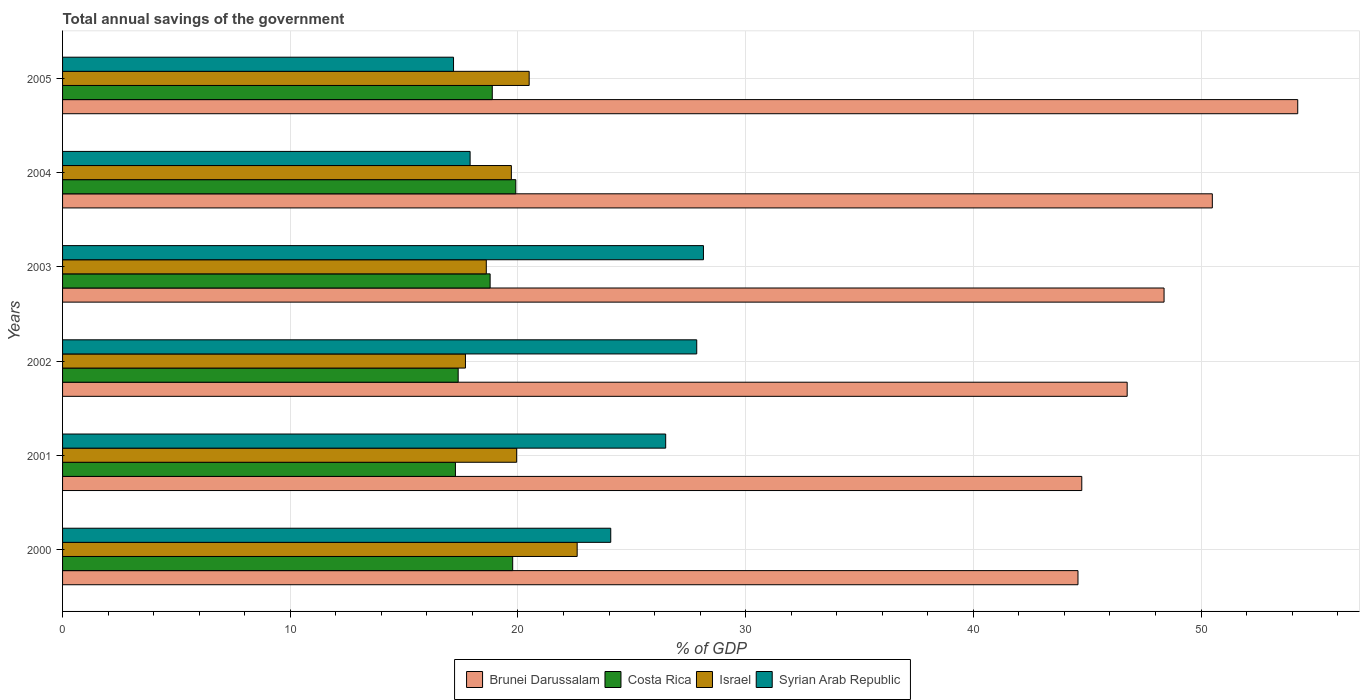How many different coloured bars are there?
Your answer should be compact. 4. How many groups of bars are there?
Provide a short and direct response. 6. Are the number of bars on each tick of the Y-axis equal?
Provide a short and direct response. Yes. How many bars are there on the 2nd tick from the top?
Offer a very short reply. 4. What is the total annual savings of the government in Brunei Darussalam in 2001?
Your response must be concise. 44.76. Across all years, what is the maximum total annual savings of the government in Brunei Darussalam?
Ensure brevity in your answer.  54.25. Across all years, what is the minimum total annual savings of the government in Israel?
Offer a very short reply. 17.69. In which year was the total annual savings of the government in Israel maximum?
Offer a very short reply. 2000. In which year was the total annual savings of the government in Brunei Darussalam minimum?
Your answer should be very brief. 2000. What is the total total annual savings of the government in Brunei Darussalam in the graph?
Offer a very short reply. 289.23. What is the difference between the total annual savings of the government in Syrian Arab Republic in 2003 and that in 2004?
Your answer should be very brief. 10.25. What is the difference between the total annual savings of the government in Costa Rica in 2005 and the total annual savings of the government in Brunei Darussalam in 2002?
Your answer should be very brief. -27.88. What is the average total annual savings of the government in Syrian Arab Republic per year?
Ensure brevity in your answer.  23.6. In the year 2001, what is the difference between the total annual savings of the government in Syrian Arab Republic and total annual savings of the government in Israel?
Provide a short and direct response. 6.55. What is the ratio of the total annual savings of the government in Brunei Darussalam in 2002 to that in 2003?
Your answer should be compact. 0.97. What is the difference between the highest and the second highest total annual savings of the government in Costa Rica?
Offer a very short reply. 0.14. What is the difference between the highest and the lowest total annual savings of the government in Costa Rica?
Your response must be concise. 2.65. In how many years, is the total annual savings of the government in Israel greater than the average total annual savings of the government in Israel taken over all years?
Your response must be concise. 3. Is the sum of the total annual savings of the government in Syrian Arab Republic in 2004 and 2005 greater than the maximum total annual savings of the government in Brunei Darussalam across all years?
Provide a succinct answer. No. What does the 2nd bar from the bottom in 2000 represents?
Provide a succinct answer. Costa Rica. How many bars are there?
Your response must be concise. 24. Are all the bars in the graph horizontal?
Your answer should be compact. Yes. How many years are there in the graph?
Provide a short and direct response. 6. Are the values on the major ticks of X-axis written in scientific E-notation?
Give a very brief answer. No. Does the graph contain grids?
Your answer should be very brief. Yes. Where does the legend appear in the graph?
Offer a very short reply. Bottom center. How many legend labels are there?
Keep it short and to the point. 4. What is the title of the graph?
Make the answer very short. Total annual savings of the government. Does "Liechtenstein" appear as one of the legend labels in the graph?
Offer a very short reply. No. What is the label or title of the X-axis?
Provide a succinct answer. % of GDP. What is the % of GDP of Brunei Darussalam in 2000?
Your answer should be very brief. 44.59. What is the % of GDP in Costa Rica in 2000?
Your answer should be very brief. 19.77. What is the % of GDP of Israel in 2000?
Your answer should be very brief. 22.6. What is the % of GDP in Syrian Arab Republic in 2000?
Offer a very short reply. 24.08. What is the % of GDP in Brunei Darussalam in 2001?
Ensure brevity in your answer.  44.76. What is the % of GDP in Costa Rica in 2001?
Your response must be concise. 17.25. What is the % of GDP in Israel in 2001?
Your answer should be very brief. 19.94. What is the % of GDP of Syrian Arab Republic in 2001?
Provide a succinct answer. 26.49. What is the % of GDP of Brunei Darussalam in 2002?
Ensure brevity in your answer.  46.76. What is the % of GDP of Costa Rica in 2002?
Give a very brief answer. 17.37. What is the % of GDP in Israel in 2002?
Your answer should be very brief. 17.69. What is the % of GDP of Syrian Arab Republic in 2002?
Your answer should be very brief. 27.85. What is the % of GDP of Brunei Darussalam in 2003?
Ensure brevity in your answer.  48.38. What is the % of GDP in Costa Rica in 2003?
Offer a terse response. 18.78. What is the % of GDP in Israel in 2003?
Offer a very short reply. 18.61. What is the % of GDP of Syrian Arab Republic in 2003?
Make the answer very short. 28.15. What is the % of GDP in Brunei Darussalam in 2004?
Keep it short and to the point. 50.49. What is the % of GDP in Costa Rica in 2004?
Provide a succinct answer. 19.91. What is the % of GDP of Israel in 2004?
Give a very brief answer. 19.71. What is the % of GDP of Syrian Arab Republic in 2004?
Your answer should be very brief. 17.9. What is the % of GDP of Brunei Darussalam in 2005?
Keep it short and to the point. 54.25. What is the % of GDP of Costa Rica in 2005?
Your answer should be very brief. 18.87. What is the % of GDP of Israel in 2005?
Ensure brevity in your answer.  20.49. What is the % of GDP of Syrian Arab Republic in 2005?
Offer a very short reply. 17.17. Across all years, what is the maximum % of GDP of Brunei Darussalam?
Offer a very short reply. 54.25. Across all years, what is the maximum % of GDP of Costa Rica?
Offer a very short reply. 19.91. Across all years, what is the maximum % of GDP of Israel?
Offer a very short reply. 22.6. Across all years, what is the maximum % of GDP of Syrian Arab Republic?
Give a very brief answer. 28.15. Across all years, what is the minimum % of GDP of Brunei Darussalam?
Provide a succinct answer. 44.59. Across all years, what is the minimum % of GDP of Costa Rica?
Provide a succinct answer. 17.25. Across all years, what is the minimum % of GDP of Israel?
Offer a very short reply. 17.69. Across all years, what is the minimum % of GDP of Syrian Arab Republic?
Keep it short and to the point. 17.17. What is the total % of GDP of Brunei Darussalam in the graph?
Keep it short and to the point. 289.23. What is the total % of GDP of Costa Rica in the graph?
Give a very brief answer. 111.95. What is the total % of GDP of Israel in the graph?
Ensure brevity in your answer.  119.05. What is the total % of GDP of Syrian Arab Republic in the graph?
Offer a terse response. 141.63. What is the difference between the % of GDP in Brunei Darussalam in 2000 and that in 2001?
Ensure brevity in your answer.  -0.17. What is the difference between the % of GDP of Costa Rica in 2000 and that in 2001?
Give a very brief answer. 2.51. What is the difference between the % of GDP of Israel in 2000 and that in 2001?
Offer a terse response. 2.66. What is the difference between the % of GDP of Syrian Arab Republic in 2000 and that in 2001?
Offer a very short reply. -2.41. What is the difference between the % of GDP in Brunei Darussalam in 2000 and that in 2002?
Give a very brief answer. -2.16. What is the difference between the % of GDP of Costa Rica in 2000 and that in 2002?
Offer a terse response. 2.39. What is the difference between the % of GDP of Israel in 2000 and that in 2002?
Provide a succinct answer. 4.91. What is the difference between the % of GDP of Syrian Arab Republic in 2000 and that in 2002?
Ensure brevity in your answer.  -3.78. What is the difference between the % of GDP of Brunei Darussalam in 2000 and that in 2003?
Make the answer very short. -3.78. What is the difference between the % of GDP in Costa Rica in 2000 and that in 2003?
Your response must be concise. 0.99. What is the difference between the % of GDP in Israel in 2000 and that in 2003?
Your response must be concise. 3.99. What is the difference between the % of GDP in Syrian Arab Republic in 2000 and that in 2003?
Your answer should be compact. -4.07. What is the difference between the % of GDP in Costa Rica in 2000 and that in 2004?
Your answer should be very brief. -0.14. What is the difference between the % of GDP of Israel in 2000 and that in 2004?
Make the answer very short. 2.89. What is the difference between the % of GDP of Syrian Arab Republic in 2000 and that in 2004?
Your answer should be very brief. 6.18. What is the difference between the % of GDP of Brunei Darussalam in 2000 and that in 2005?
Make the answer very short. -9.65. What is the difference between the % of GDP in Costa Rica in 2000 and that in 2005?
Ensure brevity in your answer.  0.9. What is the difference between the % of GDP in Israel in 2000 and that in 2005?
Give a very brief answer. 2.11. What is the difference between the % of GDP in Syrian Arab Republic in 2000 and that in 2005?
Ensure brevity in your answer.  6.91. What is the difference between the % of GDP in Brunei Darussalam in 2001 and that in 2002?
Ensure brevity in your answer.  -1.99. What is the difference between the % of GDP of Costa Rica in 2001 and that in 2002?
Make the answer very short. -0.12. What is the difference between the % of GDP in Israel in 2001 and that in 2002?
Your answer should be very brief. 2.25. What is the difference between the % of GDP in Syrian Arab Republic in 2001 and that in 2002?
Ensure brevity in your answer.  -1.36. What is the difference between the % of GDP of Brunei Darussalam in 2001 and that in 2003?
Make the answer very short. -3.61. What is the difference between the % of GDP of Costa Rica in 2001 and that in 2003?
Ensure brevity in your answer.  -1.52. What is the difference between the % of GDP of Israel in 2001 and that in 2003?
Offer a terse response. 1.33. What is the difference between the % of GDP of Syrian Arab Republic in 2001 and that in 2003?
Your answer should be compact. -1.66. What is the difference between the % of GDP in Brunei Darussalam in 2001 and that in 2004?
Provide a short and direct response. -5.73. What is the difference between the % of GDP in Costa Rica in 2001 and that in 2004?
Your answer should be compact. -2.65. What is the difference between the % of GDP of Israel in 2001 and that in 2004?
Give a very brief answer. 0.23. What is the difference between the % of GDP in Syrian Arab Republic in 2001 and that in 2004?
Provide a short and direct response. 8.59. What is the difference between the % of GDP of Brunei Darussalam in 2001 and that in 2005?
Offer a terse response. -9.48. What is the difference between the % of GDP in Costa Rica in 2001 and that in 2005?
Make the answer very short. -1.62. What is the difference between the % of GDP in Israel in 2001 and that in 2005?
Provide a succinct answer. -0.55. What is the difference between the % of GDP of Syrian Arab Republic in 2001 and that in 2005?
Ensure brevity in your answer.  9.32. What is the difference between the % of GDP in Brunei Darussalam in 2002 and that in 2003?
Offer a terse response. -1.62. What is the difference between the % of GDP in Costa Rica in 2002 and that in 2003?
Give a very brief answer. -1.4. What is the difference between the % of GDP of Israel in 2002 and that in 2003?
Your answer should be compact. -0.92. What is the difference between the % of GDP of Syrian Arab Republic in 2002 and that in 2003?
Your answer should be compact. -0.29. What is the difference between the % of GDP in Brunei Darussalam in 2002 and that in 2004?
Provide a succinct answer. -3.74. What is the difference between the % of GDP of Costa Rica in 2002 and that in 2004?
Give a very brief answer. -2.53. What is the difference between the % of GDP in Israel in 2002 and that in 2004?
Your answer should be very brief. -2.02. What is the difference between the % of GDP in Syrian Arab Republic in 2002 and that in 2004?
Make the answer very short. 9.95. What is the difference between the % of GDP of Brunei Darussalam in 2002 and that in 2005?
Keep it short and to the point. -7.49. What is the difference between the % of GDP in Costa Rica in 2002 and that in 2005?
Your response must be concise. -1.5. What is the difference between the % of GDP in Israel in 2002 and that in 2005?
Offer a terse response. -2.8. What is the difference between the % of GDP of Syrian Arab Republic in 2002 and that in 2005?
Provide a short and direct response. 10.68. What is the difference between the % of GDP of Brunei Darussalam in 2003 and that in 2004?
Make the answer very short. -2.12. What is the difference between the % of GDP of Costa Rica in 2003 and that in 2004?
Make the answer very short. -1.13. What is the difference between the % of GDP in Israel in 2003 and that in 2004?
Your answer should be compact. -1.1. What is the difference between the % of GDP in Syrian Arab Republic in 2003 and that in 2004?
Make the answer very short. 10.25. What is the difference between the % of GDP in Brunei Darussalam in 2003 and that in 2005?
Keep it short and to the point. -5.87. What is the difference between the % of GDP of Costa Rica in 2003 and that in 2005?
Ensure brevity in your answer.  -0.09. What is the difference between the % of GDP of Israel in 2003 and that in 2005?
Provide a succinct answer. -1.88. What is the difference between the % of GDP of Syrian Arab Republic in 2003 and that in 2005?
Your answer should be compact. 10.98. What is the difference between the % of GDP in Brunei Darussalam in 2004 and that in 2005?
Ensure brevity in your answer.  -3.75. What is the difference between the % of GDP in Costa Rica in 2004 and that in 2005?
Provide a succinct answer. 1.03. What is the difference between the % of GDP of Israel in 2004 and that in 2005?
Your answer should be very brief. -0.78. What is the difference between the % of GDP of Syrian Arab Republic in 2004 and that in 2005?
Provide a short and direct response. 0.73. What is the difference between the % of GDP of Brunei Darussalam in 2000 and the % of GDP of Costa Rica in 2001?
Provide a short and direct response. 27.34. What is the difference between the % of GDP in Brunei Darussalam in 2000 and the % of GDP in Israel in 2001?
Offer a very short reply. 24.65. What is the difference between the % of GDP in Brunei Darussalam in 2000 and the % of GDP in Syrian Arab Republic in 2001?
Your answer should be compact. 18.11. What is the difference between the % of GDP of Costa Rica in 2000 and the % of GDP of Israel in 2001?
Provide a short and direct response. -0.17. What is the difference between the % of GDP of Costa Rica in 2000 and the % of GDP of Syrian Arab Republic in 2001?
Provide a succinct answer. -6.72. What is the difference between the % of GDP of Israel in 2000 and the % of GDP of Syrian Arab Republic in 2001?
Make the answer very short. -3.89. What is the difference between the % of GDP in Brunei Darussalam in 2000 and the % of GDP in Costa Rica in 2002?
Your answer should be very brief. 27.22. What is the difference between the % of GDP in Brunei Darussalam in 2000 and the % of GDP in Israel in 2002?
Ensure brevity in your answer.  26.9. What is the difference between the % of GDP of Brunei Darussalam in 2000 and the % of GDP of Syrian Arab Republic in 2002?
Your answer should be compact. 16.74. What is the difference between the % of GDP in Costa Rica in 2000 and the % of GDP in Israel in 2002?
Your answer should be very brief. 2.07. What is the difference between the % of GDP of Costa Rica in 2000 and the % of GDP of Syrian Arab Republic in 2002?
Provide a short and direct response. -8.08. What is the difference between the % of GDP in Israel in 2000 and the % of GDP in Syrian Arab Republic in 2002?
Provide a succinct answer. -5.25. What is the difference between the % of GDP in Brunei Darussalam in 2000 and the % of GDP in Costa Rica in 2003?
Offer a terse response. 25.82. What is the difference between the % of GDP of Brunei Darussalam in 2000 and the % of GDP of Israel in 2003?
Your answer should be compact. 25.99. What is the difference between the % of GDP in Brunei Darussalam in 2000 and the % of GDP in Syrian Arab Republic in 2003?
Your answer should be very brief. 16.45. What is the difference between the % of GDP of Costa Rica in 2000 and the % of GDP of Israel in 2003?
Offer a very short reply. 1.16. What is the difference between the % of GDP in Costa Rica in 2000 and the % of GDP in Syrian Arab Republic in 2003?
Make the answer very short. -8.38. What is the difference between the % of GDP in Israel in 2000 and the % of GDP in Syrian Arab Republic in 2003?
Provide a succinct answer. -5.55. What is the difference between the % of GDP in Brunei Darussalam in 2000 and the % of GDP in Costa Rica in 2004?
Ensure brevity in your answer.  24.69. What is the difference between the % of GDP in Brunei Darussalam in 2000 and the % of GDP in Israel in 2004?
Your answer should be compact. 24.88. What is the difference between the % of GDP in Brunei Darussalam in 2000 and the % of GDP in Syrian Arab Republic in 2004?
Your answer should be very brief. 26.7. What is the difference between the % of GDP in Costa Rica in 2000 and the % of GDP in Israel in 2004?
Offer a terse response. 0.06. What is the difference between the % of GDP in Costa Rica in 2000 and the % of GDP in Syrian Arab Republic in 2004?
Your response must be concise. 1.87. What is the difference between the % of GDP in Israel in 2000 and the % of GDP in Syrian Arab Republic in 2004?
Offer a very short reply. 4.7. What is the difference between the % of GDP in Brunei Darussalam in 2000 and the % of GDP in Costa Rica in 2005?
Provide a succinct answer. 25.72. What is the difference between the % of GDP in Brunei Darussalam in 2000 and the % of GDP in Israel in 2005?
Your answer should be very brief. 24.1. What is the difference between the % of GDP of Brunei Darussalam in 2000 and the % of GDP of Syrian Arab Republic in 2005?
Make the answer very short. 27.42. What is the difference between the % of GDP of Costa Rica in 2000 and the % of GDP of Israel in 2005?
Offer a terse response. -0.72. What is the difference between the % of GDP in Costa Rica in 2000 and the % of GDP in Syrian Arab Republic in 2005?
Provide a short and direct response. 2.6. What is the difference between the % of GDP in Israel in 2000 and the % of GDP in Syrian Arab Republic in 2005?
Give a very brief answer. 5.43. What is the difference between the % of GDP of Brunei Darussalam in 2001 and the % of GDP of Costa Rica in 2002?
Offer a terse response. 27.39. What is the difference between the % of GDP of Brunei Darussalam in 2001 and the % of GDP of Israel in 2002?
Make the answer very short. 27.07. What is the difference between the % of GDP of Brunei Darussalam in 2001 and the % of GDP of Syrian Arab Republic in 2002?
Your answer should be very brief. 16.91. What is the difference between the % of GDP in Costa Rica in 2001 and the % of GDP in Israel in 2002?
Ensure brevity in your answer.  -0.44. What is the difference between the % of GDP in Costa Rica in 2001 and the % of GDP in Syrian Arab Republic in 2002?
Your answer should be very brief. -10.6. What is the difference between the % of GDP in Israel in 2001 and the % of GDP in Syrian Arab Republic in 2002?
Keep it short and to the point. -7.91. What is the difference between the % of GDP of Brunei Darussalam in 2001 and the % of GDP of Costa Rica in 2003?
Make the answer very short. 25.98. What is the difference between the % of GDP of Brunei Darussalam in 2001 and the % of GDP of Israel in 2003?
Offer a very short reply. 26.15. What is the difference between the % of GDP of Brunei Darussalam in 2001 and the % of GDP of Syrian Arab Republic in 2003?
Offer a very short reply. 16.62. What is the difference between the % of GDP of Costa Rica in 2001 and the % of GDP of Israel in 2003?
Your answer should be very brief. -1.36. What is the difference between the % of GDP in Costa Rica in 2001 and the % of GDP in Syrian Arab Republic in 2003?
Your response must be concise. -10.89. What is the difference between the % of GDP in Israel in 2001 and the % of GDP in Syrian Arab Republic in 2003?
Provide a short and direct response. -8.2. What is the difference between the % of GDP in Brunei Darussalam in 2001 and the % of GDP in Costa Rica in 2004?
Your answer should be compact. 24.86. What is the difference between the % of GDP in Brunei Darussalam in 2001 and the % of GDP in Israel in 2004?
Keep it short and to the point. 25.05. What is the difference between the % of GDP in Brunei Darussalam in 2001 and the % of GDP in Syrian Arab Republic in 2004?
Ensure brevity in your answer.  26.86. What is the difference between the % of GDP in Costa Rica in 2001 and the % of GDP in Israel in 2004?
Your answer should be compact. -2.46. What is the difference between the % of GDP of Costa Rica in 2001 and the % of GDP of Syrian Arab Republic in 2004?
Provide a succinct answer. -0.64. What is the difference between the % of GDP in Israel in 2001 and the % of GDP in Syrian Arab Republic in 2004?
Your answer should be very brief. 2.04. What is the difference between the % of GDP of Brunei Darussalam in 2001 and the % of GDP of Costa Rica in 2005?
Give a very brief answer. 25.89. What is the difference between the % of GDP of Brunei Darussalam in 2001 and the % of GDP of Israel in 2005?
Your response must be concise. 24.27. What is the difference between the % of GDP in Brunei Darussalam in 2001 and the % of GDP in Syrian Arab Republic in 2005?
Your answer should be compact. 27.59. What is the difference between the % of GDP in Costa Rica in 2001 and the % of GDP in Israel in 2005?
Give a very brief answer. -3.24. What is the difference between the % of GDP in Costa Rica in 2001 and the % of GDP in Syrian Arab Republic in 2005?
Provide a succinct answer. 0.08. What is the difference between the % of GDP in Israel in 2001 and the % of GDP in Syrian Arab Republic in 2005?
Your response must be concise. 2.77. What is the difference between the % of GDP of Brunei Darussalam in 2002 and the % of GDP of Costa Rica in 2003?
Your answer should be compact. 27.98. What is the difference between the % of GDP of Brunei Darussalam in 2002 and the % of GDP of Israel in 2003?
Your answer should be compact. 28.15. What is the difference between the % of GDP of Brunei Darussalam in 2002 and the % of GDP of Syrian Arab Republic in 2003?
Provide a succinct answer. 18.61. What is the difference between the % of GDP of Costa Rica in 2002 and the % of GDP of Israel in 2003?
Make the answer very short. -1.23. What is the difference between the % of GDP in Costa Rica in 2002 and the % of GDP in Syrian Arab Republic in 2003?
Your answer should be compact. -10.77. What is the difference between the % of GDP of Israel in 2002 and the % of GDP of Syrian Arab Republic in 2003?
Your answer should be very brief. -10.45. What is the difference between the % of GDP of Brunei Darussalam in 2002 and the % of GDP of Costa Rica in 2004?
Offer a terse response. 26.85. What is the difference between the % of GDP of Brunei Darussalam in 2002 and the % of GDP of Israel in 2004?
Make the answer very short. 27.05. What is the difference between the % of GDP of Brunei Darussalam in 2002 and the % of GDP of Syrian Arab Republic in 2004?
Your answer should be very brief. 28.86. What is the difference between the % of GDP of Costa Rica in 2002 and the % of GDP of Israel in 2004?
Your answer should be very brief. -2.34. What is the difference between the % of GDP of Costa Rica in 2002 and the % of GDP of Syrian Arab Republic in 2004?
Your response must be concise. -0.52. What is the difference between the % of GDP of Israel in 2002 and the % of GDP of Syrian Arab Republic in 2004?
Provide a succinct answer. -0.2. What is the difference between the % of GDP in Brunei Darussalam in 2002 and the % of GDP in Costa Rica in 2005?
Make the answer very short. 27.88. What is the difference between the % of GDP of Brunei Darussalam in 2002 and the % of GDP of Israel in 2005?
Give a very brief answer. 26.26. What is the difference between the % of GDP in Brunei Darussalam in 2002 and the % of GDP in Syrian Arab Republic in 2005?
Your answer should be compact. 29.59. What is the difference between the % of GDP in Costa Rica in 2002 and the % of GDP in Israel in 2005?
Your response must be concise. -3.12. What is the difference between the % of GDP in Costa Rica in 2002 and the % of GDP in Syrian Arab Republic in 2005?
Ensure brevity in your answer.  0.2. What is the difference between the % of GDP in Israel in 2002 and the % of GDP in Syrian Arab Republic in 2005?
Keep it short and to the point. 0.52. What is the difference between the % of GDP of Brunei Darussalam in 2003 and the % of GDP of Costa Rica in 2004?
Provide a short and direct response. 28.47. What is the difference between the % of GDP in Brunei Darussalam in 2003 and the % of GDP in Israel in 2004?
Make the answer very short. 28.67. What is the difference between the % of GDP in Brunei Darussalam in 2003 and the % of GDP in Syrian Arab Republic in 2004?
Make the answer very short. 30.48. What is the difference between the % of GDP of Costa Rica in 2003 and the % of GDP of Israel in 2004?
Provide a short and direct response. -0.93. What is the difference between the % of GDP in Costa Rica in 2003 and the % of GDP in Syrian Arab Republic in 2004?
Keep it short and to the point. 0.88. What is the difference between the % of GDP of Israel in 2003 and the % of GDP of Syrian Arab Republic in 2004?
Make the answer very short. 0.71. What is the difference between the % of GDP of Brunei Darussalam in 2003 and the % of GDP of Costa Rica in 2005?
Make the answer very short. 29.5. What is the difference between the % of GDP of Brunei Darussalam in 2003 and the % of GDP of Israel in 2005?
Keep it short and to the point. 27.88. What is the difference between the % of GDP in Brunei Darussalam in 2003 and the % of GDP in Syrian Arab Republic in 2005?
Provide a succinct answer. 31.21. What is the difference between the % of GDP in Costa Rica in 2003 and the % of GDP in Israel in 2005?
Make the answer very short. -1.72. What is the difference between the % of GDP of Costa Rica in 2003 and the % of GDP of Syrian Arab Republic in 2005?
Keep it short and to the point. 1.61. What is the difference between the % of GDP of Israel in 2003 and the % of GDP of Syrian Arab Republic in 2005?
Your answer should be very brief. 1.44. What is the difference between the % of GDP of Brunei Darussalam in 2004 and the % of GDP of Costa Rica in 2005?
Ensure brevity in your answer.  31.62. What is the difference between the % of GDP of Brunei Darussalam in 2004 and the % of GDP of Israel in 2005?
Your response must be concise. 30. What is the difference between the % of GDP of Brunei Darussalam in 2004 and the % of GDP of Syrian Arab Republic in 2005?
Your response must be concise. 33.32. What is the difference between the % of GDP of Costa Rica in 2004 and the % of GDP of Israel in 2005?
Your answer should be compact. -0.59. What is the difference between the % of GDP of Costa Rica in 2004 and the % of GDP of Syrian Arab Republic in 2005?
Your answer should be compact. 2.73. What is the difference between the % of GDP in Israel in 2004 and the % of GDP in Syrian Arab Republic in 2005?
Your response must be concise. 2.54. What is the average % of GDP of Brunei Darussalam per year?
Provide a short and direct response. 48.2. What is the average % of GDP of Costa Rica per year?
Make the answer very short. 18.66. What is the average % of GDP in Israel per year?
Your answer should be very brief. 19.84. What is the average % of GDP in Syrian Arab Republic per year?
Your response must be concise. 23.61. In the year 2000, what is the difference between the % of GDP of Brunei Darussalam and % of GDP of Costa Rica?
Provide a succinct answer. 24.83. In the year 2000, what is the difference between the % of GDP in Brunei Darussalam and % of GDP in Israel?
Offer a terse response. 21.99. In the year 2000, what is the difference between the % of GDP of Brunei Darussalam and % of GDP of Syrian Arab Republic?
Keep it short and to the point. 20.52. In the year 2000, what is the difference between the % of GDP of Costa Rica and % of GDP of Israel?
Give a very brief answer. -2.83. In the year 2000, what is the difference between the % of GDP in Costa Rica and % of GDP in Syrian Arab Republic?
Ensure brevity in your answer.  -4.31. In the year 2000, what is the difference between the % of GDP in Israel and % of GDP in Syrian Arab Republic?
Provide a short and direct response. -1.48. In the year 2001, what is the difference between the % of GDP in Brunei Darussalam and % of GDP in Costa Rica?
Make the answer very short. 27.51. In the year 2001, what is the difference between the % of GDP in Brunei Darussalam and % of GDP in Israel?
Your answer should be compact. 24.82. In the year 2001, what is the difference between the % of GDP of Brunei Darussalam and % of GDP of Syrian Arab Republic?
Your answer should be very brief. 18.27. In the year 2001, what is the difference between the % of GDP in Costa Rica and % of GDP in Israel?
Offer a very short reply. -2.69. In the year 2001, what is the difference between the % of GDP of Costa Rica and % of GDP of Syrian Arab Republic?
Give a very brief answer. -9.23. In the year 2001, what is the difference between the % of GDP in Israel and % of GDP in Syrian Arab Republic?
Offer a very short reply. -6.54. In the year 2002, what is the difference between the % of GDP of Brunei Darussalam and % of GDP of Costa Rica?
Keep it short and to the point. 29.38. In the year 2002, what is the difference between the % of GDP in Brunei Darussalam and % of GDP in Israel?
Offer a very short reply. 29.06. In the year 2002, what is the difference between the % of GDP in Brunei Darussalam and % of GDP in Syrian Arab Republic?
Offer a terse response. 18.9. In the year 2002, what is the difference between the % of GDP in Costa Rica and % of GDP in Israel?
Ensure brevity in your answer.  -0.32. In the year 2002, what is the difference between the % of GDP of Costa Rica and % of GDP of Syrian Arab Republic?
Ensure brevity in your answer.  -10.48. In the year 2002, what is the difference between the % of GDP of Israel and % of GDP of Syrian Arab Republic?
Offer a very short reply. -10.16. In the year 2003, what is the difference between the % of GDP of Brunei Darussalam and % of GDP of Costa Rica?
Make the answer very short. 29.6. In the year 2003, what is the difference between the % of GDP of Brunei Darussalam and % of GDP of Israel?
Your response must be concise. 29.77. In the year 2003, what is the difference between the % of GDP of Brunei Darussalam and % of GDP of Syrian Arab Republic?
Give a very brief answer. 20.23. In the year 2003, what is the difference between the % of GDP of Costa Rica and % of GDP of Israel?
Your answer should be compact. 0.17. In the year 2003, what is the difference between the % of GDP in Costa Rica and % of GDP in Syrian Arab Republic?
Provide a short and direct response. -9.37. In the year 2003, what is the difference between the % of GDP in Israel and % of GDP in Syrian Arab Republic?
Offer a terse response. -9.54. In the year 2004, what is the difference between the % of GDP in Brunei Darussalam and % of GDP in Costa Rica?
Ensure brevity in your answer.  30.59. In the year 2004, what is the difference between the % of GDP in Brunei Darussalam and % of GDP in Israel?
Your response must be concise. 30.78. In the year 2004, what is the difference between the % of GDP of Brunei Darussalam and % of GDP of Syrian Arab Republic?
Your answer should be very brief. 32.6. In the year 2004, what is the difference between the % of GDP of Costa Rica and % of GDP of Israel?
Make the answer very short. 0.19. In the year 2004, what is the difference between the % of GDP of Costa Rica and % of GDP of Syrian Arab Republic?
Provide a succinct answer. 2.01. In the year 2004, what is the difference between the % of GDP in Israel and % of GDP in Syrian Arab Republic?
Offer a terse response. 1.81. In the year 2005, what is the difference between the % of GDP of Brunei Darussalam and % of GDP of Costa Rica?
Make the answer very short. 35.37. In the year 2005, what is the difference between the % of GDP of Brunei Darussalam and % of GDP of Israel?
Keep it short and to the point. 33.75. In the year 2005, what is the difference between the % of GDP of Brunei Darussalam and % of GDP of Syrian Arab Republic?
Your answer should be compact. 37.08. In the year 2005, what is the difference between the % of GDP of Costa Rica and % of GDP of Israel?
Offer a very short reply. -1.62. In the year 2005, what is the difference between the % of GDP of Costa Rica and % of GDP of Syrian Arab Republic?
Ensure brevity in your answer.  1.7. In the year 2005, what is the difference between the % of GDP of Israel and % of GDP of Syrian Arab Republic?
Provide a short and direct response. 3.32. What is the ratio of the % of GDP in Costa Rica in 2000 to that in 2001?
Offer a very short reply. 1.15. What is the ratio of the % of GDP of Israel in 2000 to that in 2001?
Provide a succinct answer. 1.13. What is the ratio of the % of GDP in Syrian Arab Republic in 2000 to that in 2001?
Offer a terse response. 0.91. What is the ratio of the % of GDP in Brunei Darussalam in 2000 to that in 2002?
Keep it short and to the point. 0.95. What is the ratio of the % of GDP in Costa Rica in 2000 to that in 2002?
Offer a terse response. 1.14. What is the ratio of the % of GDP in Israel in 2000 to that in 2002?
Your answer should be compact. 1.28. What is the ratio of the % of GDP of Syrian Arab Republic in 2000 to that in 2002?
Provide a succinct answer. 0.86. What is the ratio of the % of GDP in Brunei Darussalam in 2000 to that in 2003?
Ensure brevity in your answer.  0.92. What is the ratio of the % of GDP of Costa Rica in 2000 to that in 2003?
Make the answer very short. 1.05. What is the ratio of the % of GDP of Israel in 2000 to that in 2003?
Your answer should be compact. 1.21. What is the ratio of the % of GDP in Syrian Arab Republic in 2000 to that in 2003?
Provide a succinct answer. 0.86. What is the ratio of the % of GDP of Brunei Darussalam in 2000 to that in 2004?
Ensure brevity in your answer.  0.88. What is the ratio of the % of GDP in Costa Rica in 2000 to that in 2004?
Ensure brevity in your answer.  0.99. What is the ratio of the % of GDP in Israel in 2000 to that in 2004?
Provide a short and direct response. 1.15. What is the ratio of the % of GDP of Syrian Arab Republic in 2000 to that in 2004?
Offer a terse response. 1.35. What is the ratio of the % of GDP of Brunei Darussalam in 2000 to that in 2005?
Give a very brief answer. 0.82. What is the ratio of the % of GDP in Costa Rica in 2000 to that in 2005?
Give a very brief answer. 1.05. What is the ratio of the % of GDP in Israel in 2000 to that in 2005?
Provide a short and direct response. 1.1. What is the ratio of the % of GDP in Syrian Arab Republic in 2000 to that in 2005?
Offer a very short reply. 1.4. What is the ratio of the % of GDP in Brunei Darussalam in 2001 to that in 2002?
Give a very brief answer. 0.96. What is the ratio of the % of GDP in Israel in 2001 to that in 2002?
Ensure brevity in your answer.  1.13. What is the ratio of the % of GDP in Syrian Arab Republic in 2001 to that in 2002?
Your answer should be compact. 0.95. What is the ratio of the % of GDP in Brunei Darussalam in 2001 to that in 2003?
Provide a succinct answer. 0.93. What is the ratio of the % of GDP in Costa Rica in 2001 to that in 2003?
Your answer should be compact. 0.92. What is the ratio of the % of GDP of Israel in 2001 to that in 2003?
Keep it short and to the point. 1.07. What is the ratio of the % of GDP in Syrian Arab Republic in 2001 to that in 2003?
Keep it short and to the point. 0.94. What is the ratio of the % of GDP of Brunei Darussalam in 2001 to that in 2004?
Your response must be concise. 0.89. What is the ratio of the % of GDP in Costa Rica in 2001 to that in 2004?
Give a very brief answer. 0.87. What is the ratio of the % of GDP of Israel in 2001 to that in 2004?
Make the answer very short. 1.01. What is the ratio of the % of GDP in Syrian Arab Republic in 2001 to that in 2004?
Offer a terse response. 1.48. What is the ratio of the % of GDP in Brunei Darussalam in 2001 to that in 2005?
Keep it short and to the point. 0.83. What is the ratio of the % of GDP of Costa Rica in 2001 to that in 2005?
Offer a very short reply. 0.91. What is the ratio of the % of GDP of Israel in 2001 to that in 2005?
Provide a succinct answer. 0.97. What is the ratio of the % of GDP of Syrian Arab Republic in 2001 to that in 2005?
Your answer should be compact. 1.54. What is the ratio of the % of GDP of Brunei Darussalam in 2002 to that in 2003?
Make the answer very short. 0.97. What is the ratio of the % of GDP in Costa Rica in 2002 to that in 2003?
Give a very brief answer. 0.93. What is the ratio of the % of GDP of Israel in 2002 to that in 2003?
Provide a short and direct response. 0.95. What is the ratio of the % of GDP of Brunei Darussalam in 2002 to that in 2004?
Keep it short and to the point. 0.93. What is the ratio of the % of GDP in Costa Rica in 2002 to that in 2004?
Offer a very short reply. 0.87. What is the ratio of the % of GDP of Israel in 2002 to that in 2004?
Provide a succinct answer. 0.9. What is the ratio of the % of GDP of Syrian Arab Republic in 2002 to that in 2004?
Keep it short and to the point. 1.56. What is the ratio of the % of GDP of Brunei Darussalam in 2002 to that in 2005?
Provide a succinct answer. 0.86. What is the ratio of the % of GDP of Costa Rica in 2002 to that in 2005?
Your answer should be very brief. 0.92. What is the ratio of the % of GDP in Israel in 2002 to that in 2005?
Your answer should be very brief. 0.86. What is the ratio of the % of GDP of Syrian Arab Republic in 2002 to that in 2005?
Offer a very short reply. 1.62. What is the ratio of the % of GDP in Brunei Darussalam in 2003 to that in 2004?
Ensure brevity in your answer.  0.96. What is the ratio of the % of GDP in Costa Rica in 2003 to that in 2004?
Provide a short and direct response. 0.94. What is the ratio of the % of GDP of Israel in 2003 to that in 2004?
Ensure brevity in your answer.  0.94. What is the ratio of the % of GDP in Syrian Arab Republic in 2003 to that in 2004?
Offer a terse response. 1.57. What is the ratio of the % of GDP of Brunei Darussalam in 2003 to that in 2005?
Keep it short and to the point. 0.89. What is the ratio of the % of GDP in Israel in 2003 to that in 2005?
Ensure brevity in your answer.  0.91. What is the ratio of the % of GDP of Syrian Arab Republic in 2003 to that in 2005?
Offer a terse response. 1.64. What is the ratio of the % of GDP of Brunei Darussalam in 2004 to that in 2005?
Your answer should be very brief. 0.93. What is the ratio of the % of GDP in Costa Rica in 2004 to that in 2005?
Ensure brevity in your answer.  1.05. What is the ratio of the % of GDP in Israel in 2004 to that in 2005?
Keep it short and to the point. 0.96. What is the ratio of the % of GDP in Syrian Arab Republic in 2004 to that in 2005?
Offer a very short reply. 1.04. What is the difference between the highest and the second highest % of GDP of Brunei Darussalam?
Offer a terse response. 3.75. What is the difference between the highest and the second highest % of GDP of Costa Rica?
Provide a succinct answer. 0.14. What is the difference between the highest and the second highest % of GDP in Israel?
Offer a terse response. 2.11. What is the difference between the highest and the second highest % of GDP of Syrian Arab Republic?
Keep it short and to the point. 0.29. What is the difference between the highest and the lowest % of GDP of Brunei Darussalam?
Give a very brief answer. 9.65. What is the difference between the highest and the lowest % of GDP of Costa Rica?
Keep it short and to the point. 2.65. What is the difference between the highest and the lowest % of GDP of Israel?
Provide a short and direct response. 4.91. What is the difference between the highest and the lowest % of GDP of Syrian Arab Republic?
Your response must be concise. 10.98. 